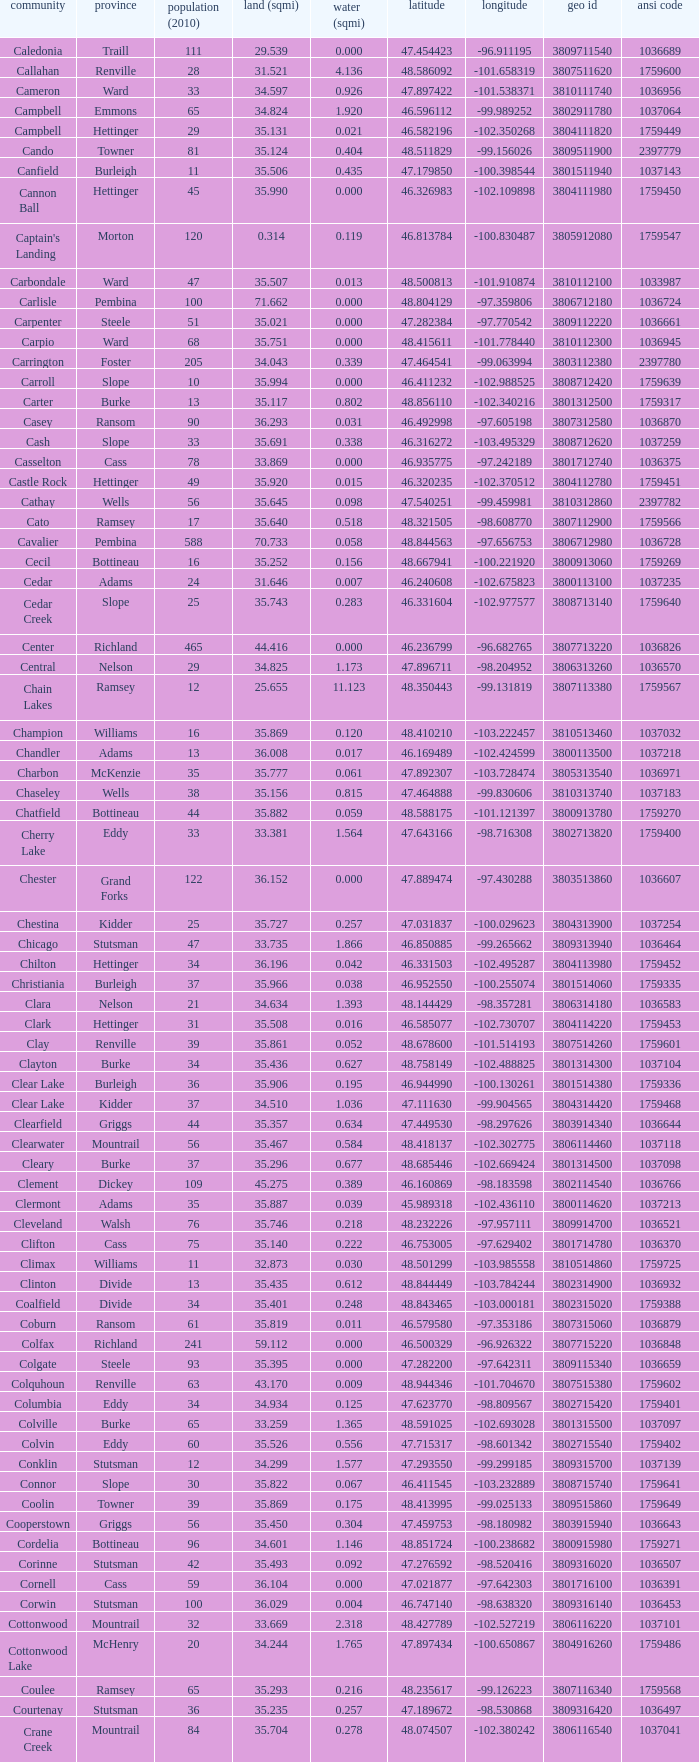What was the longitude of the township with a latitude of 48.075823? -98.857272. 